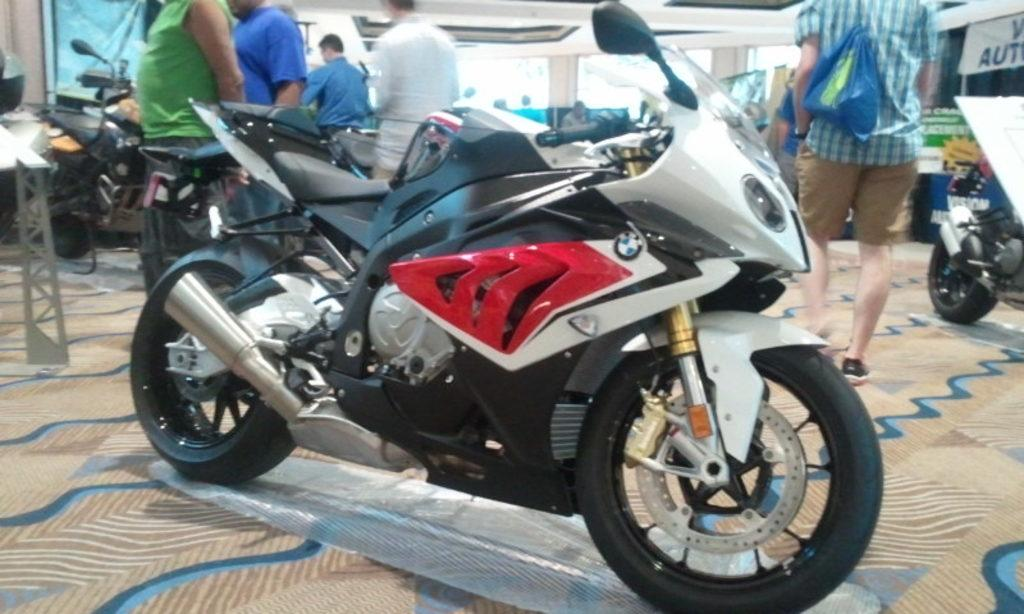What type of vehicles are in the image? There are bikes in the image. What are the people in the image doing? The people are on the floor in the image. What other objects can be seen in the image? There are boards in the image. What part of the room is visible in the image? The ceiling is visible in the image. What color is the chalk used by the person on the bike in the image? There is no chalk or person on a bike present in the image. Can you hear the thunder in the image? There is no sound or indication of thunder in the image. 